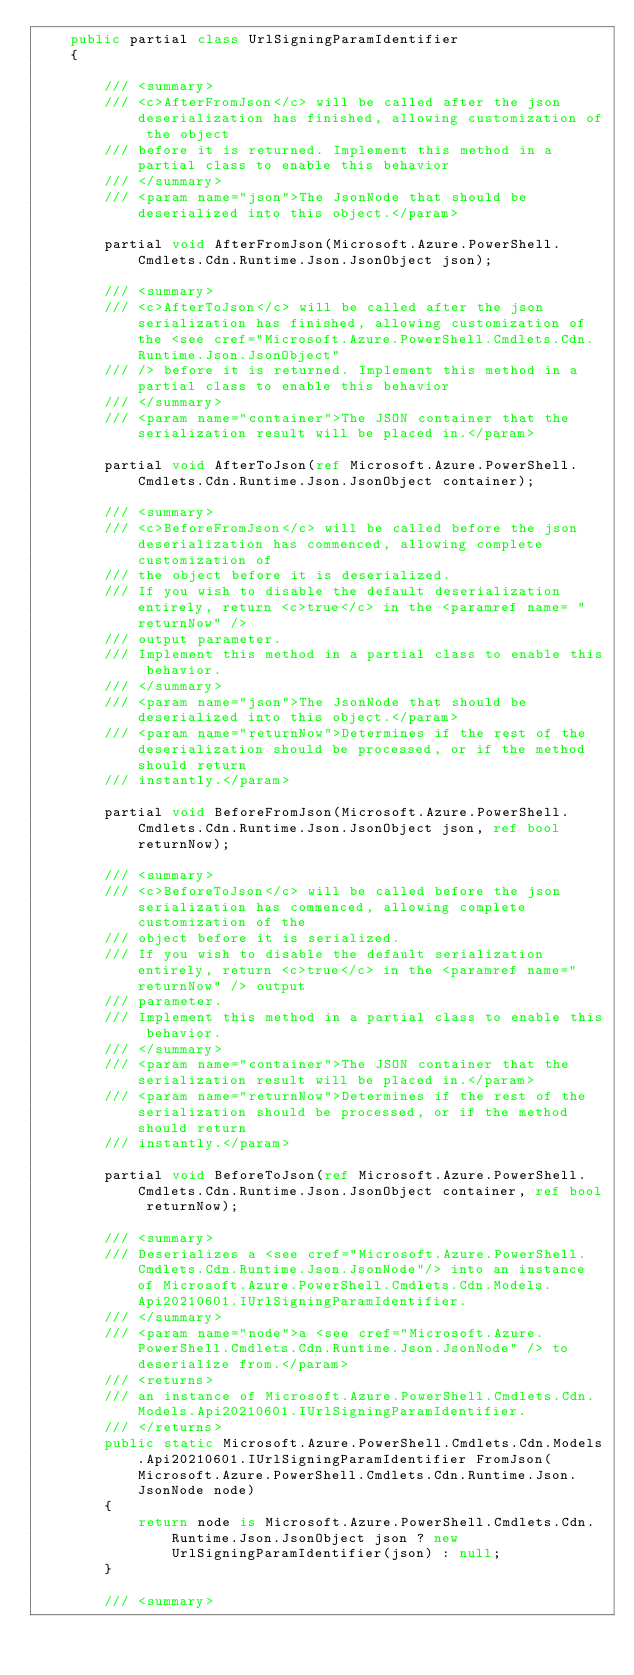<code> <loc_0><loc_0><loc_500><loc_500><_C#_>    public partial class UrlSigningParamIdentifier
    {

        /// <summary>
        /// <c>AfterFromJson</c> will be called after the json deserialization has finished, allowing customization of the object
        /// before it is returned. Implement this method in a partial class to enable this behavior
        /// </summary>
        /// <param name="json">The JsonNode that should be deserialized into this object.</param>

        partial void AfterFromJson(Microsoft.Azure.PowerShell.Cmdlets.Cdn.Runtime.Json.JsonObject json);

        /// <summary>
        /// <c>AfterToJson</c> will be called after the json serialization has finished, allowing customization of the <see cref="Microsoft.Azure.PowerShell.Cmdlets.Cdn.Runtime.Json.JsonObject"
        /// /> before it is returned. Implement this method in a partial class to enable this behavior
        /// </summary>
        /// <param name="container">The JSON container that the serialization result will be placed in.</param>

        partial void AfterToJson(ref Microsoft.Azure.PowerShell.Cmdlets.Cdn.Runtime.Json.JsonObject container);

        /// <summary>
        /// <c>BeforeFromJson</c> will be called before the json deserialization has commenced, allowing complete customization of
        /// the object before it is deserialized.
        /// If you wish to disable the default deserialization entirely, return <c>true</c> in the <paramref name= "returnNow" />
        /// output parameter.
        /// Implement this method in a partial class to enable this behavior.
        /// </summary>
        /// <param name="json">The JsonNode that should be deserialized into this object.</param>
        /// <param name="returnNow">Determines if the rest of the deserialization should be processed, or if the method should return
        /// instantly.</param>

        partial void BeforeFromJson(Microsoft.Azure.PowerShell.Cmdlets.Cdn.Runtime.Json.JsonObject json, ref bool returnNow);

        /// <summary>
        /// <c>BeforeToJson</c> will be called before the json serialization has commenced, allowing complete customization of the
        /// object before it is serialized.
        /// If you wish to disable the default serialization entirely, return <c>true</c> in the <paramref name="returnNow" /> output
        /// parameter.
        /// Implement this method in a partial class to enable this behavior.
        /// </summary>
        /// <param name="container">The JSON container that the serialization result will be placed in.</param>
        /// <param name="returnNow">Determines if the rest of the serialization should be processed, or if the method should return
        /// instantly.</param>

        partial void BeforeToJson(ref Microsoft.Azure.PowerShell.Cmdlets.Cdn.Runtime.Json.JsonObject container, ref bool returnNow);

        /// <summary>
        /// Deserializes a <see cref="Microsoft.Azure.PowerShell.Cmdlets.Cdn.Runtime.Json.JsonNode"/> into an instance of Microsoft.Azure.PowerShell.Cmdlets.Cdn.Models.Api20210601.IUrlSigningParamIdentifier.
        /// </summary>
        /// <param name="node">a <see cref="Microsoft.Azure.PowerShell.Cmdlets.Cdn.Runtime.Json.JsonNode" /> to deserialize from.</param>
        /// <returns>
        /// an instance of Microsoft.Azure.PowerShell.Cmdlets.Cdn.Models.Api20210601.IUrlSigningParamIdentifier.
        /// </returns>
        public static Microsoft.Azure.PowerShell.Cmdlets.Cdn.Models.Api20210601.IUrlSigningParamIdentifier FromJson(Microsoft.Azure.PowerShell.Cmdlets.Cdn.Runtime.Json.JsonNode node)
        {
            return node is Microsoft.Azure.PowerShell.Cmdlets.Cdn.Runtime.Json.JsonObject json ? new UrlSigningParamIdentifier(json) : null;
        }

        /// <summary></code> 